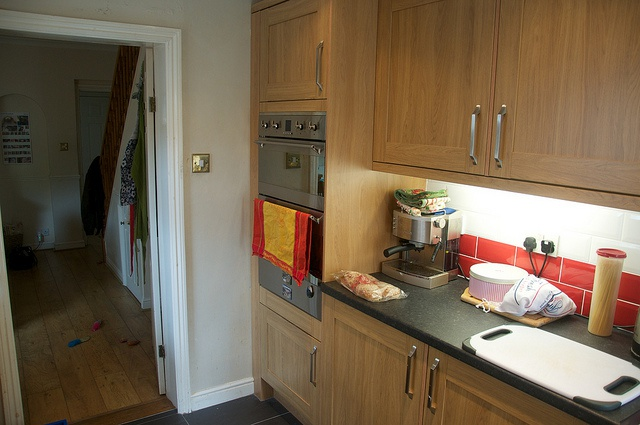Describe the objects in this image and their specific colors. I can see a oven in gray, black, and brown tones in this image. 